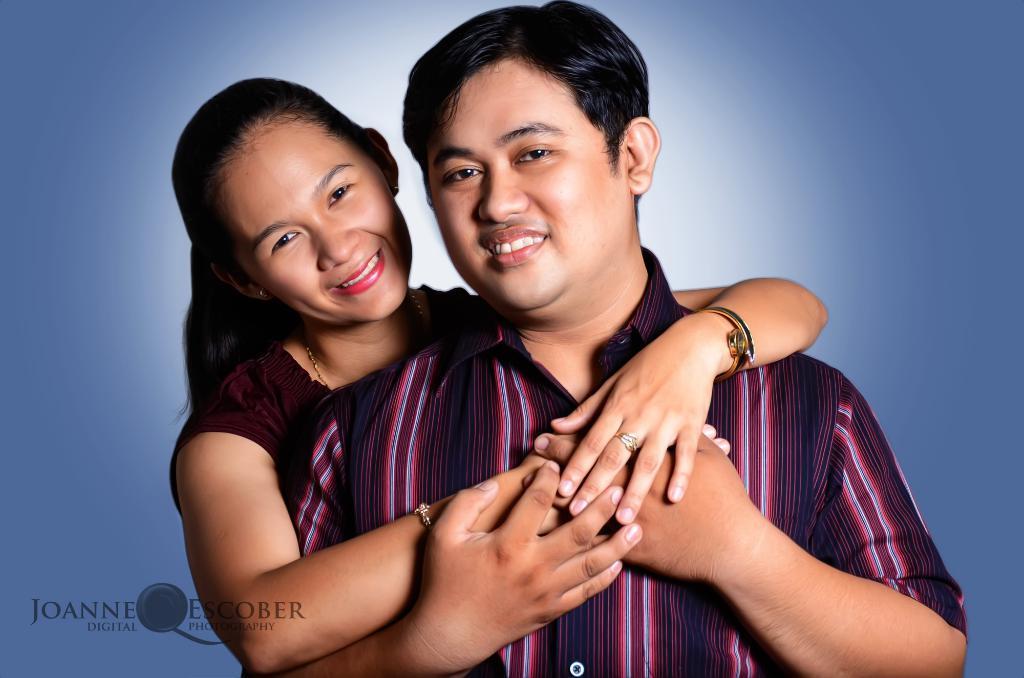Can you describe this image briefly? In this image we can see two persons with smiling faces holding each other, some text on the bottom left side of the image and there is a light blue color background. 